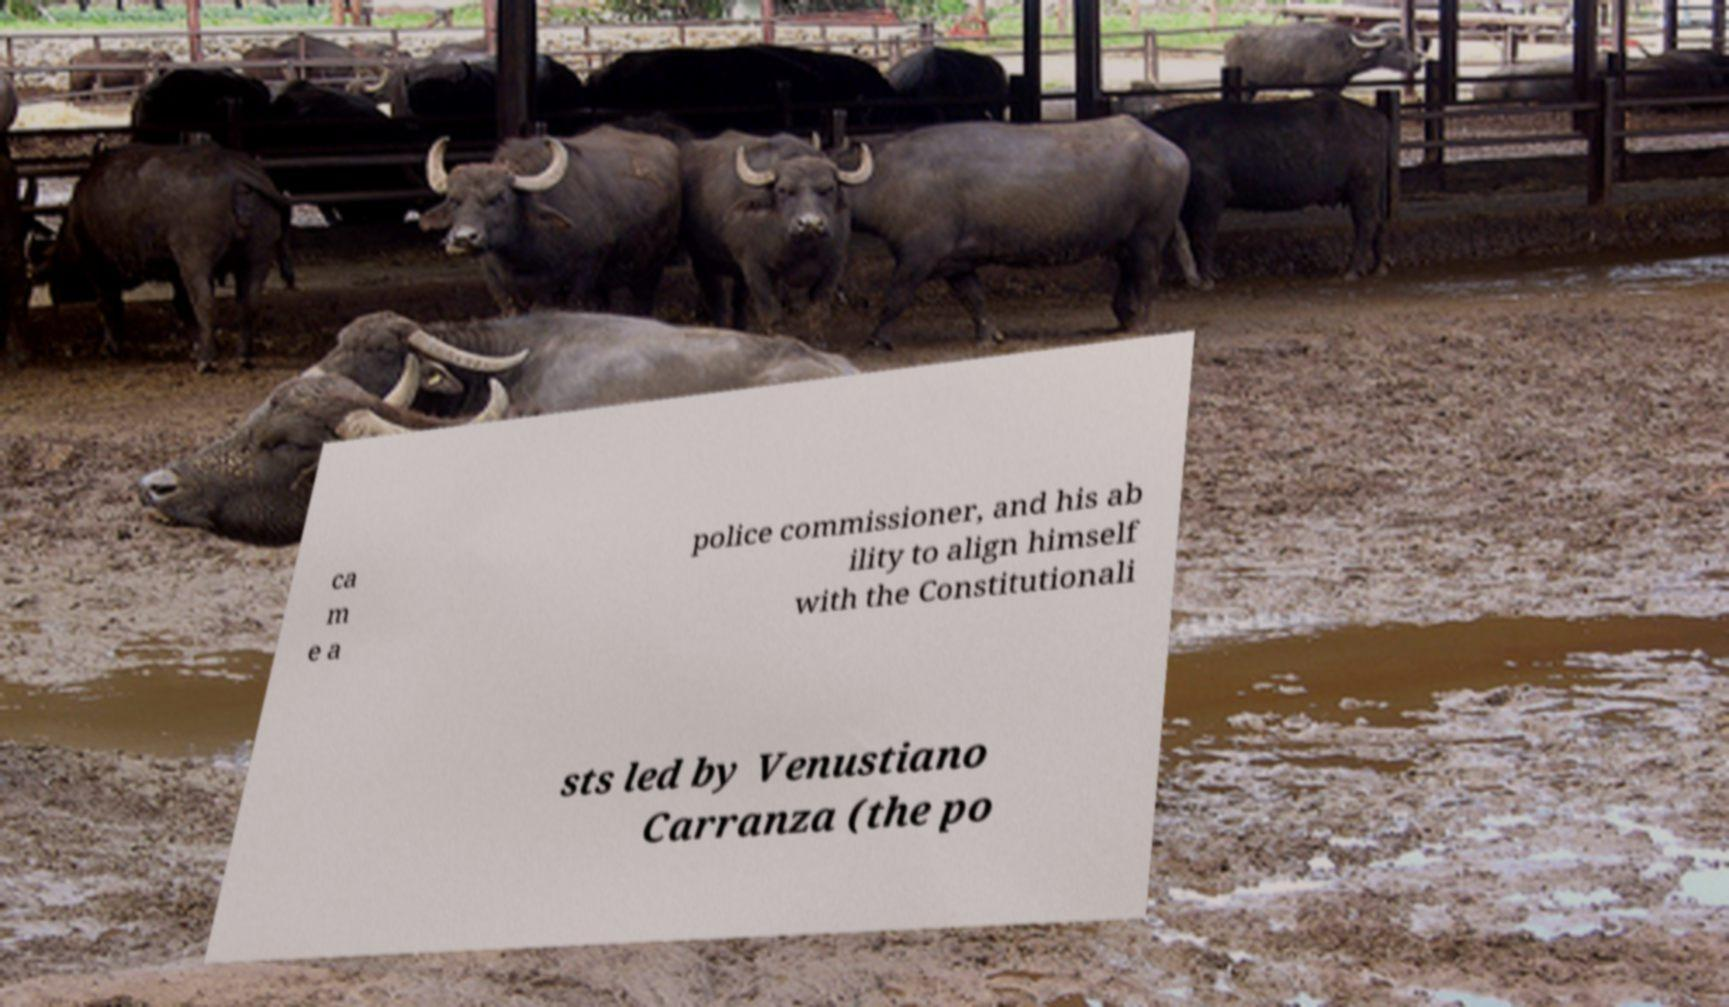There's text embedded in this image that I need extracted. Can you transcribe it verbatim? ca m e a police commissioner, and his ab ility to align himself with the Constitutionali sts led by Venustiano Carranza (the po 